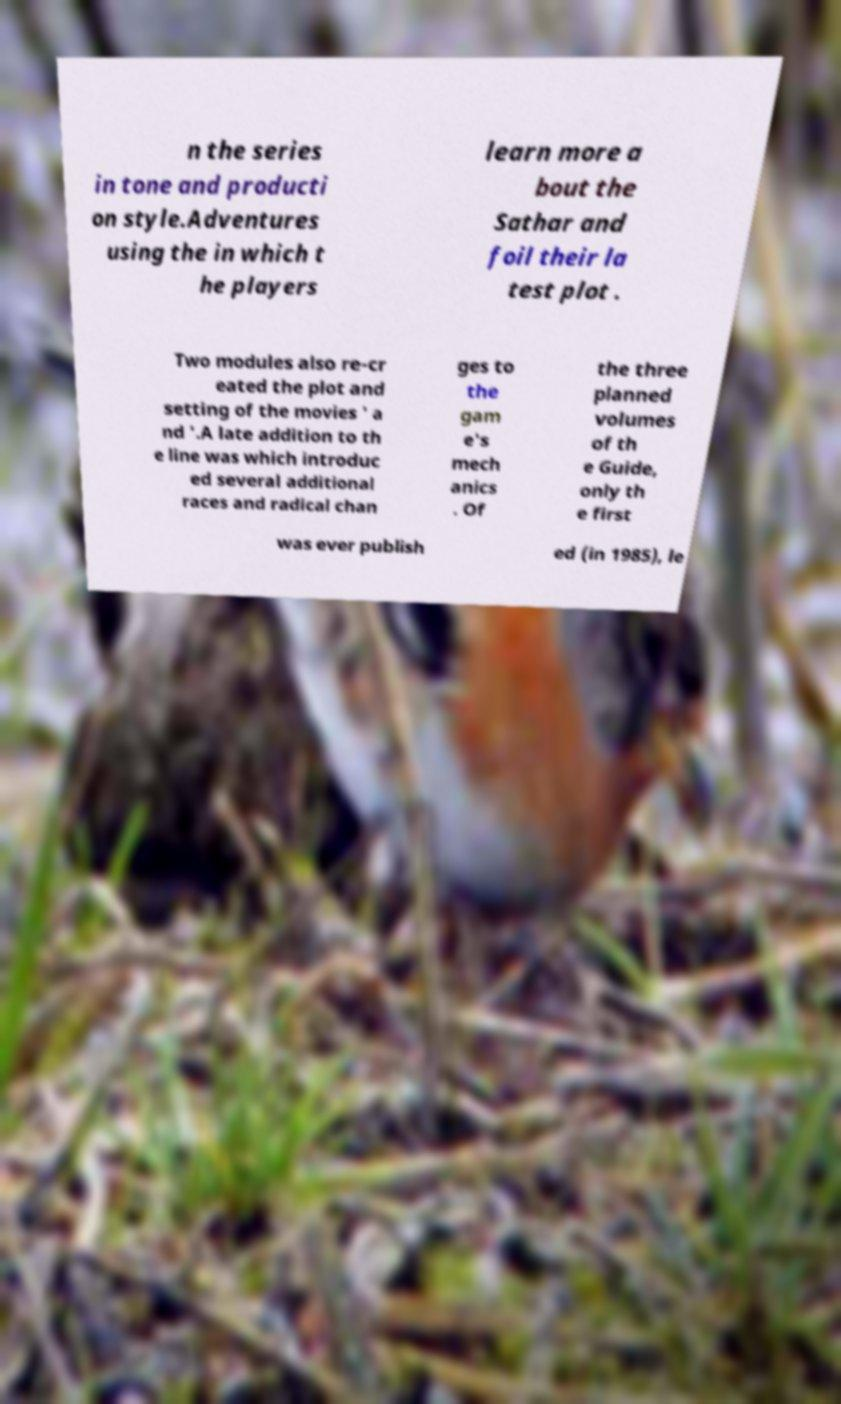There's text embedded in this image that I need extracted. Can you transcribe it verbatim? n the series in tone and producti on style.Adventures using the in which t he players learn more a bout the Sathar and foil their la test plot . Two modules also re-cr eated the plot and setting of the movies ' a nd '.A late addition to th e line was which introduc ed several additional races and radical chan ges to the gam e's mech anics . Of the three planned volumes of th e Guide, only th e first was ever publish ed (in 1985), le 